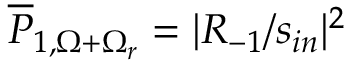<formula> <loc_0><loc_0><loc_500><loc_500>\overline { P } _ { 1 , \Omega + \Omega _ { r } } = | R _ { - 1 } / s _ { i n } | ^ { 2 }</formula> 